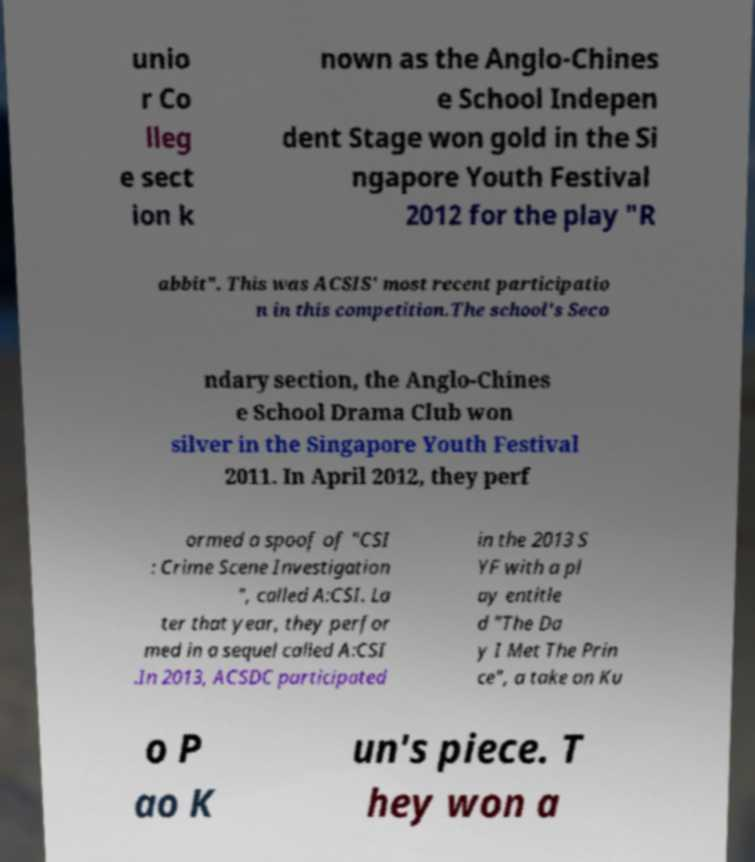For documentation purposes, I need the text within this image transcribed. Could you provide that? unio r Co lleg e sect ion k nown as the Anglo-Chines e School Indepen dent Stage won gold in the Si ngapore Youth Festival 2012 for the play "R abbit". This was ACSIS' most recent participatio n in this competition.The school's Seco ndary section, the Anglo-Chines e School Drama Club won silver in the Singapore Youth Festival 2011. In April 2012, they perf ormed a spoof of "CSI : Crime Scene Investigation ", called A:CSI. La ter that year, they perfor med in a sequel called A:CSI .In 2013, ACSDC participated in the 2013 S YF with a pl ay entitle d "The Da y I Met The Prin ce", a take on Ku o P ao K un's piece. T hey won a 